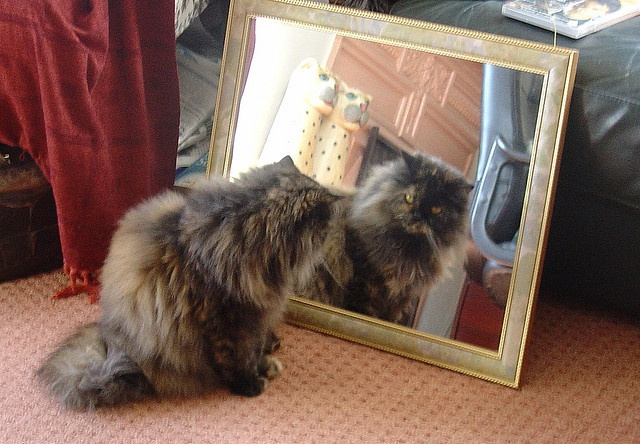Describe the objects in this image and their specific colors. I can see a cat in brown, black, gray, and maroon tones in this image. 